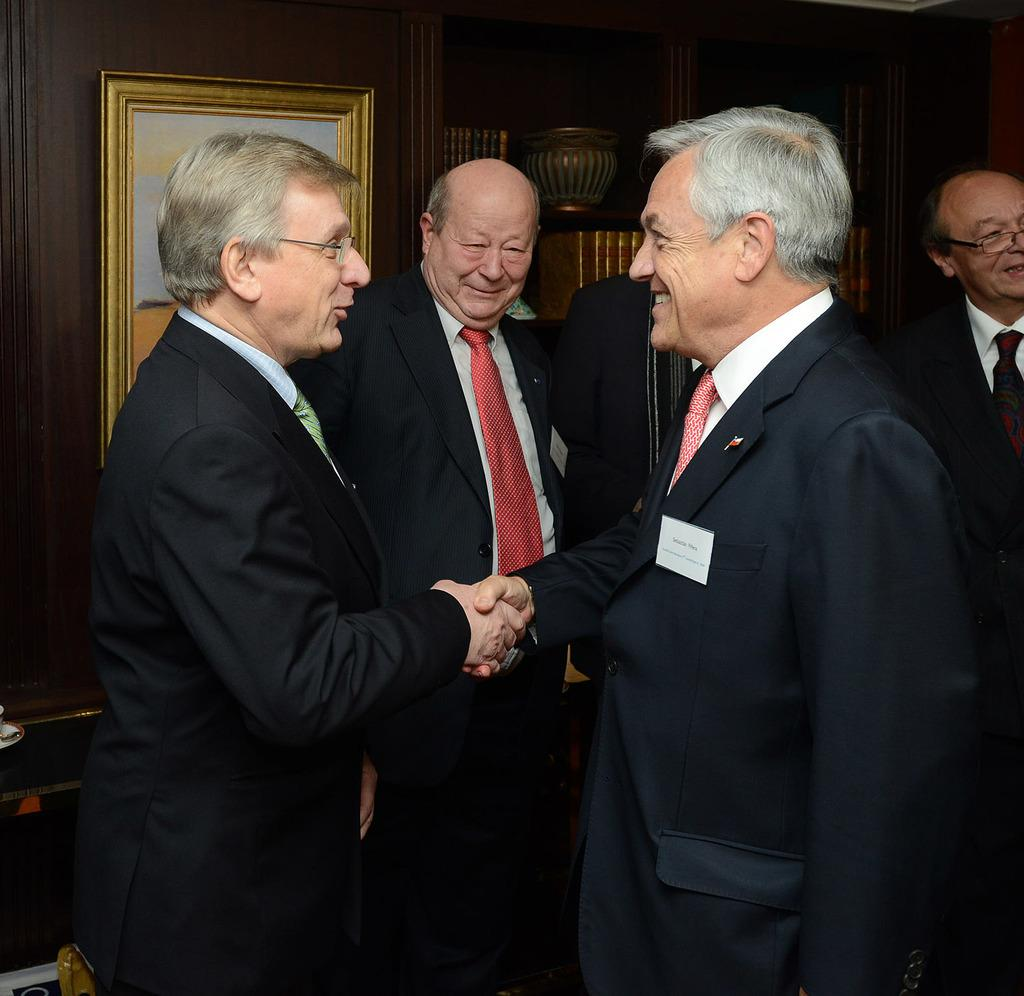How many people are present in the image? There are five persons in the image. What are the two persons in the front doing? The two persons in the front are shaking hands. Can you describe any objects in the background of the image? There is a photo frame visible in the background. What types of pets are present in the image? There are no pets visible in the image. Can you describe the guide that is helping the persons in the image? There is no guide present in the image; the two persons in the front are shaking hands without any assistance. 